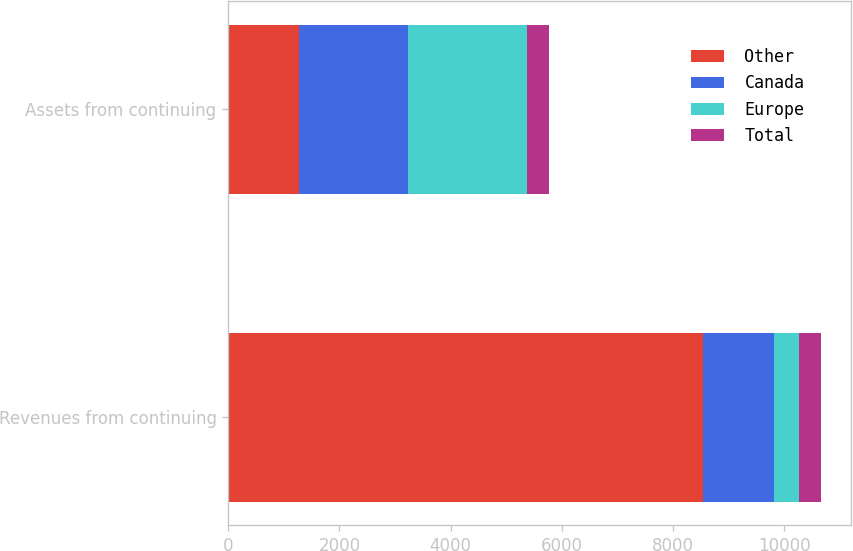<chart> <loc_0><loc_0><loc_500><loc_500><stacked_bar_chart><ecel><fcel>Revenues from continuing<fcel>Assets from continuing<nl><fcel>Other<fcel>8542.5<fcel>1269.8<nl><fcel>Canada<fcel>1269.8<fcel>1969.7<nl><fcel>Europe<fcel>447.5<fcel>2130.5<nl><fcel>Total<fcel>405.4<fcel>390.3<nl></chart> 